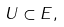<formula> <loc_0><loc_0><loc_500><loc_500>U \subset E ,</formula> 